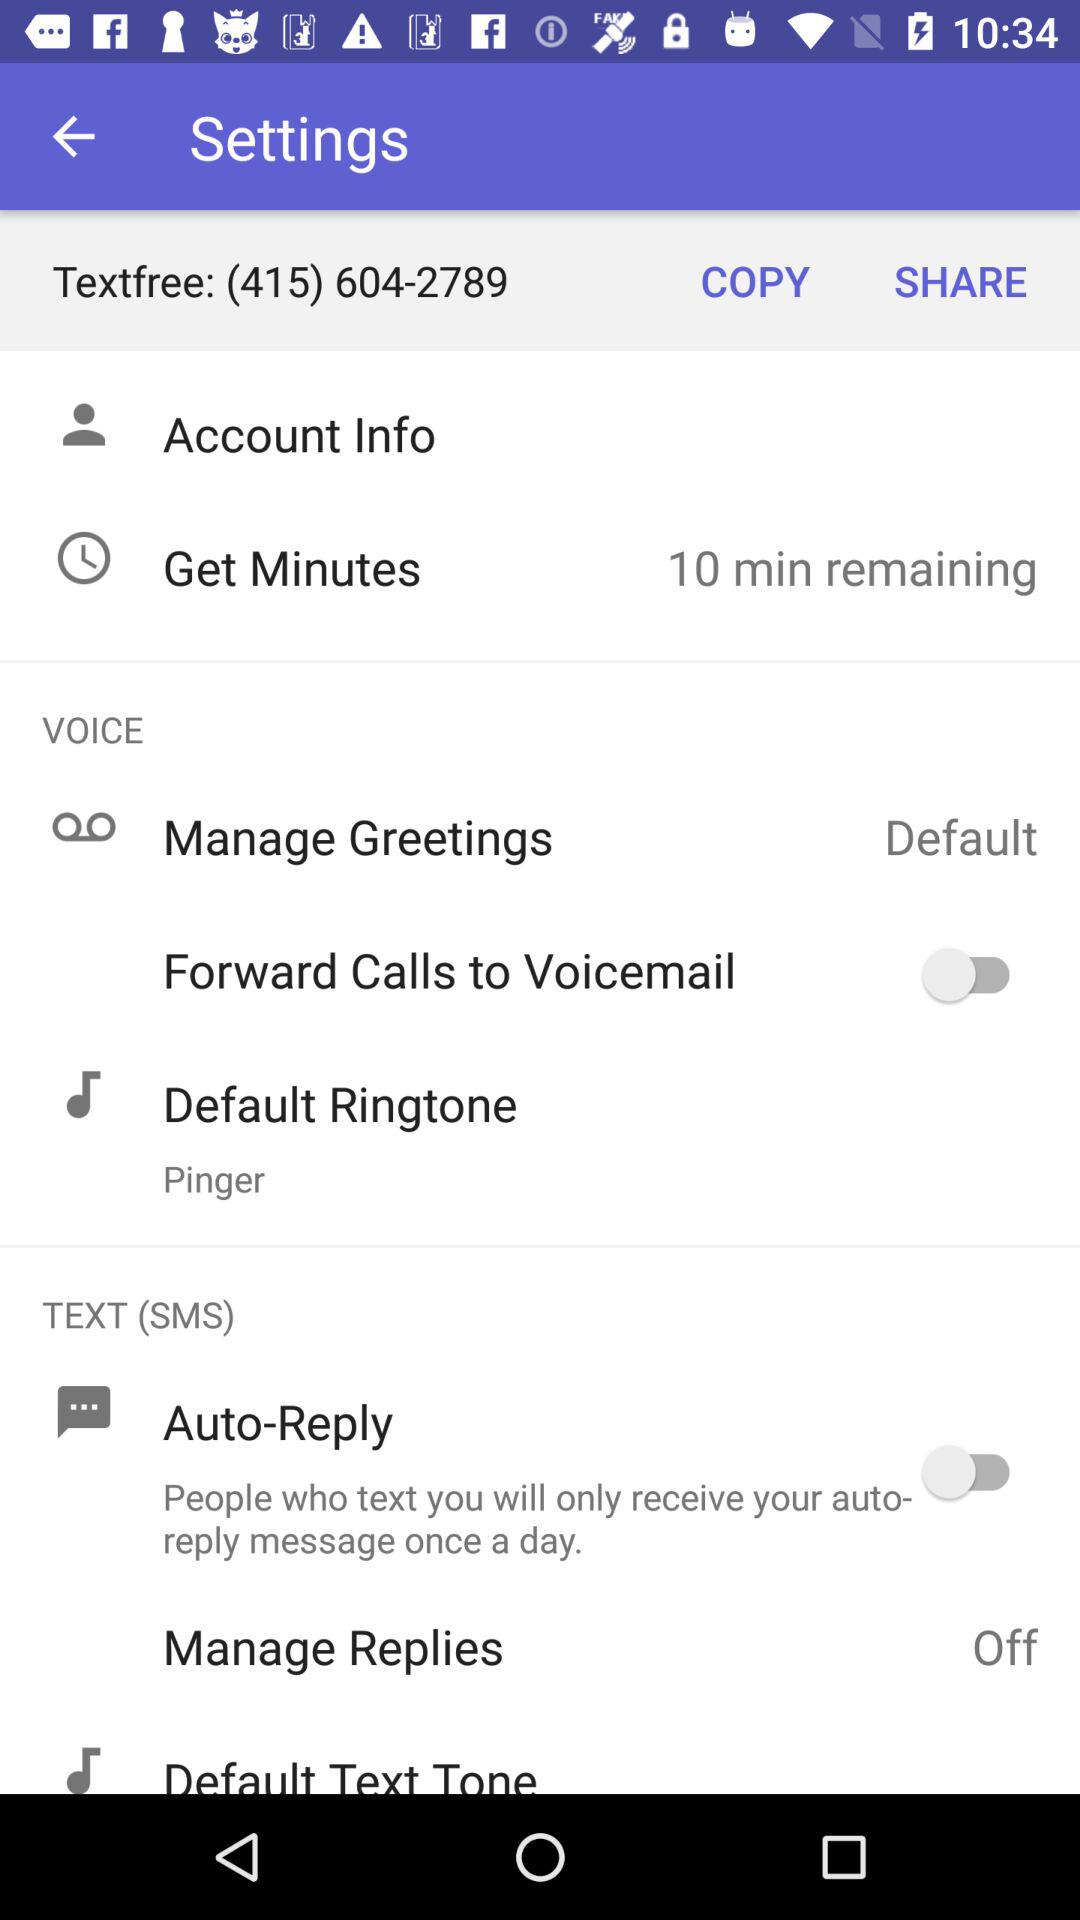What is the text-free number? The text-free number is (415) 604-2789. 